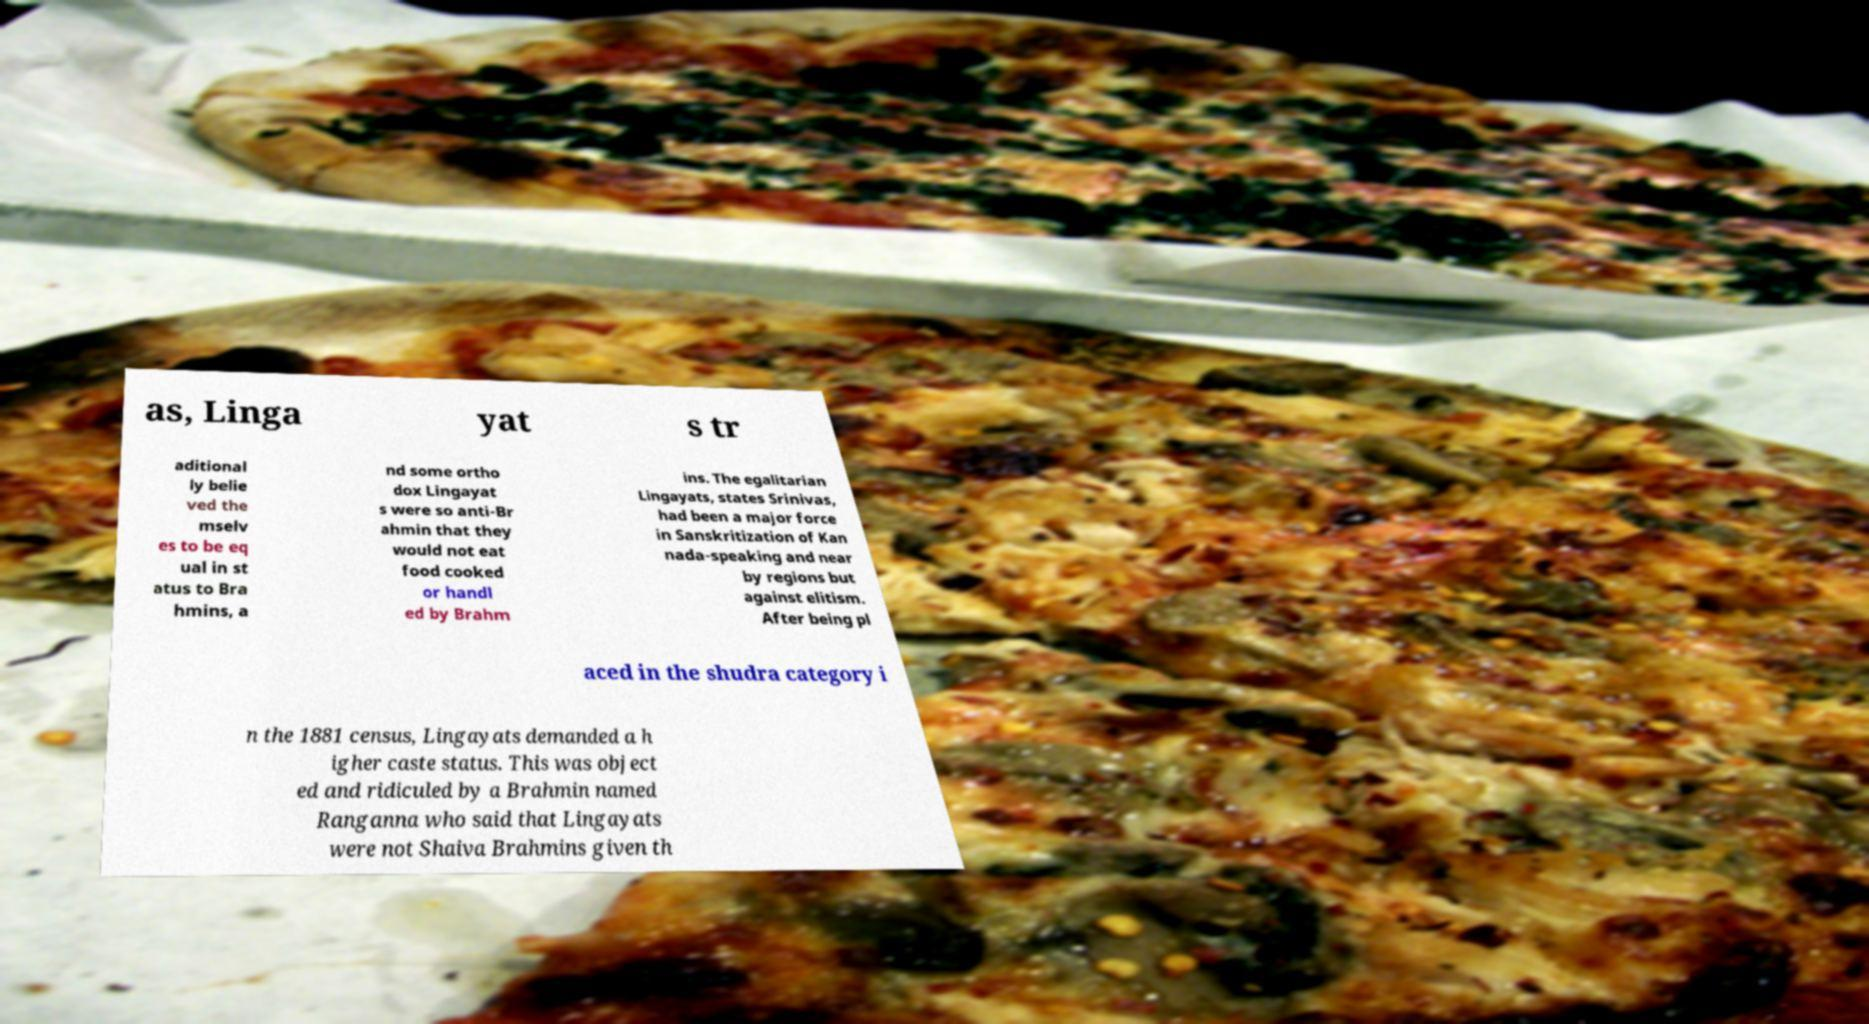There's text embedded in this image that I need extracted. Can you transcribe it verbatim? as, Linga yat s tr aditional ly belie ved the mselv es to be eq ual in st atus to Bra hmins, a nd some ortho dox Lingayat s were so anti-Br ahmin that they would not eat food cooked or handl ed by Brahm ins. The egalitarian Lingayats, states Srinivas, had been a major force in Sanskritization of Kan nada-speaking and near by regions but against elitism. After being pl aced in the shudra category i n the 1881 census, Lingayats demanded a h igher caste status. This was object ed and ridiculed by a Brahmin named Ranganna who said that Lingayats were not Shaiva Brahmins given th 